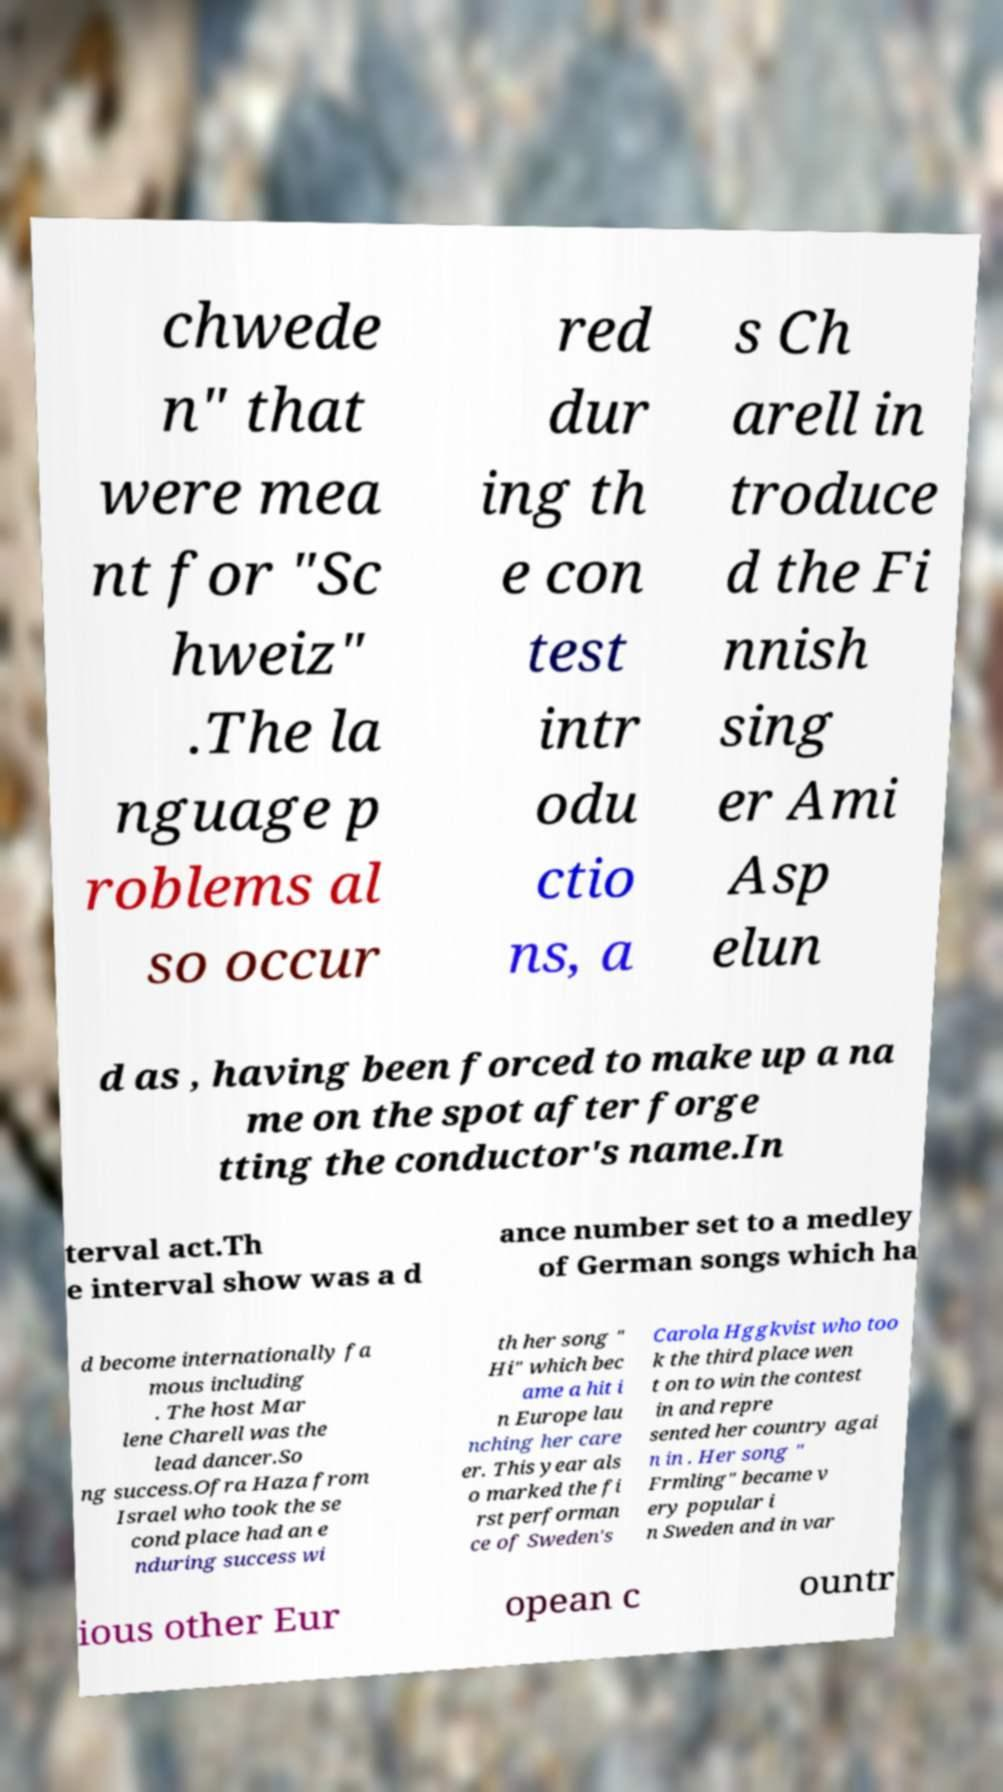For documentation purposes, I need the text within this image transcribed. Could you provide that? chwede n" that were mea nt for "Sc hweiz" .The la nguage p roblems al so occur red dur ing th e con test intr odu ctio ns, a s Ch arell in troduce d the Fi nnish sing er Ami Asp elun d as , having been forced to make up a na me on the spot after forge tting the conductor's name.In terval act.Th e interval show was a d ance number set to a medley of German songs which ha d become internationally fa mous including . The host Mar lene Charell was the lead dancer.So ng success.Ofra Haza from Israel who took the se cond place had an e nduring success wi th her song " Hi" which bec ame a hit i n Europe lau nching her care er. This year als o marked the fi rst performan ce of Sweden's Carola Hggkvist who too k the third place wen t on to win the contest in and repre sented her country agai n in . Her song " Frmling" became v ery popular i n Sweden and in var ious other Eur opean c ountr 